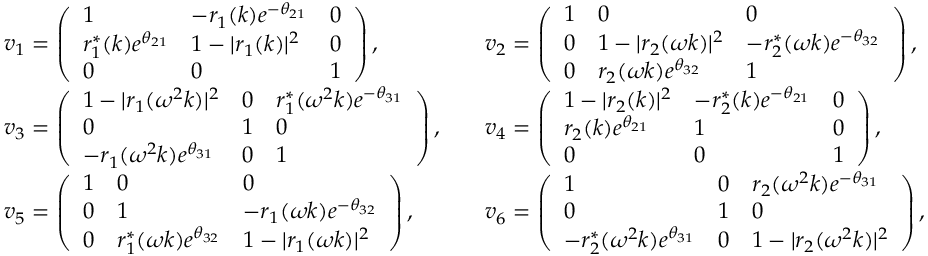Convert formula to latex. <formula><loc_0><loc_0><loc_500><loc_500>\begin{array} { r l r l } & { v _ { 1 } = \left ( \begin{array} { l l l } { 1 } & { - r _ { 1 } ( k ) e ^ { - \theta _ { 2 1 } } } & { 0 } \\ { r _ { 1 } ^ { * } ( k ) e ^ { \theta _ { 2 1 } } } & { 1 - | r _ { 1 } ( k ) | ^ { 2 } } & { 0 } \\ { 0 } & { 0 } & { 1 } \end{array} \right ) , } & & { v _ { 2 } = \left ( \begin{array} { l l l } { 1 } & { 0 } & { 0 } \\ { 0 } & { 1 - | r _ { 2 } ( \omega k ) | ^ { 2 } } & { - r _ { 2 } ^ { * } ( \omega k ) e ^ { - \theta _ { 3 2 } } } \\ { 0 } & { r _ { 2 } ( \omega k ) e ^ { \theta _ { 3 2 } } } & { 1 } \end{array} \right ) , } \\ & { v _ { 3 } = \left ( \begin{array} { l l l } { 1 - | r _ { 1 } ( \omega ^ { 2 } k ) | ^ { 2 } } & { 0 } & { r _ { 1 } ^ { * } ( \omega ^ { 2 } k ) e ^ { - \theta _ { 3 1 } } } \\ { 0 } & { 1 } & { 0 } \\ { - r _ { 1 } ( \omega ^ { 2 } k ) e ^ { \theta _ { 3 1 } } } & { 0 } & { 1 } \end{array} \right ) , } & & { v _ { 4 } = \left ( \begin{array} { l l l } { 1 - | r _ { 2 } ( k ) | ^ { 2 } } & { - r _ { 2 } ^ { * } ( k ) e ^ { - \theta _ { 2 1 } } } & { 0 } \\ { r _ { 2 } ( k ) e ^ { \theta _ { 2 1 } } } & { 1 } & { 0 } \\ { 0 } & { 0 } & { 1 } \end{array} \right ) , } \\ & { v _ { 5 } = \left ( \begin{array} { l l l } { 1 } & { 0 } & { 0 } \\ { 0 } & { 1 } & { - r _ { 1 } ( \omega k ) e ^ { - \theta _ { 3 2 } } } \\ { 0 } & { r _ { 1 } ^ { * } ( \omega k ) e ^ { \theta _ { 3 2 } } } & { 1 - | r _ { 1 } ( \omega k ) | ^ { 2 } } \end{array} \right ) , } & & { v _ { 6 } = \left ( \begin{array} { l l l } { 1 } & { 0 } & { r _ { 2 } ( \omega ^ { 2 } k ) e ^ { - \theta _ { 3 1 } } } \\ { 0 } & { 1 } & { 0 } \\ { - r _ { 2 } ^ { * } ( \omega ^ { 2 } k ) e ^ { \theta _ { 3 1 } } } & { 0 } & { 1 - | r _ { 2 } ( \omega ^ { 2 } k ) | ^ { 2 } } \end{array} \right ) , } \end{array}</formula> 